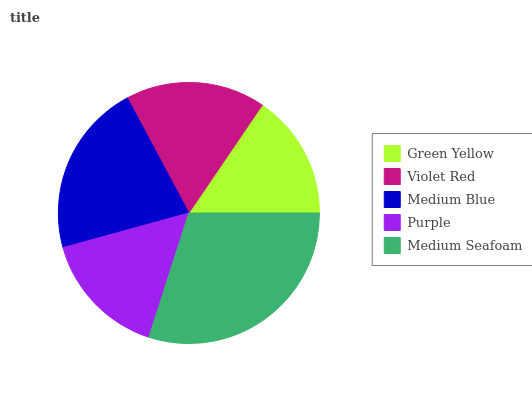Is Green Yellow the minimum?
Answer yes or no. Yes. Is Medium Seafoam the maximum?
Answer yes or no. Yes. Is Violet Red the minimum?
Answer yes or no. No. Is Violet Red the maximum?
Answer yes or no. No. Is Violet Red greater than Green Yellow?
Answer yes or no. Yes. Is Green Yellow less than Violet Red?
Answer yes or no. Yes. Is Green Yellow greater than Violet Red?
Answer yes or no. No. Is Violet Red less than Green Yellow?
Answer yes or no. No. Is Violet Red the high median?
Answer yes or no. Yes. Is Violet Red the low median?
Answer yes or no. Yes. Is Green Yellow the high median?
Answer yes or no. No. Is Green Yellow the low median?
Answer yes or no. No. 